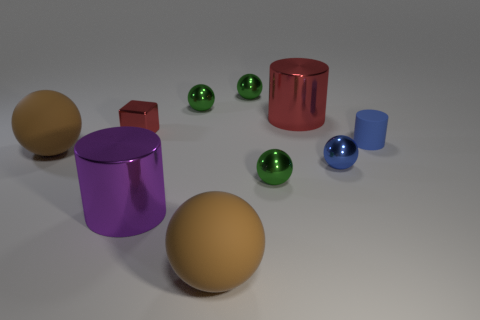Subtract all tiny blue matte cylinders. How many cylinders are left? 2 Subtract all blue spheres. How many spheres are left? 5 Subtract all cubes. How many objects are left? 9 Subtract 2 spheres. How many spheres are left? 4 Subtract all green spheres. Subtract all cyan cylinders. How many spheres are left? 3 Subtract all blue cylinders. How many brown balls are left? 2 Subtract all blue metal spheres. Subtract all small cylinders. How many objects are left? 8 Add 4 big red metal cylinders. How many big red metal cylinders are left? 5 Add 1 big metallic things. How many big metallic things exist? 3 Subtract 0 brown cubes. How many objects are left? 10 